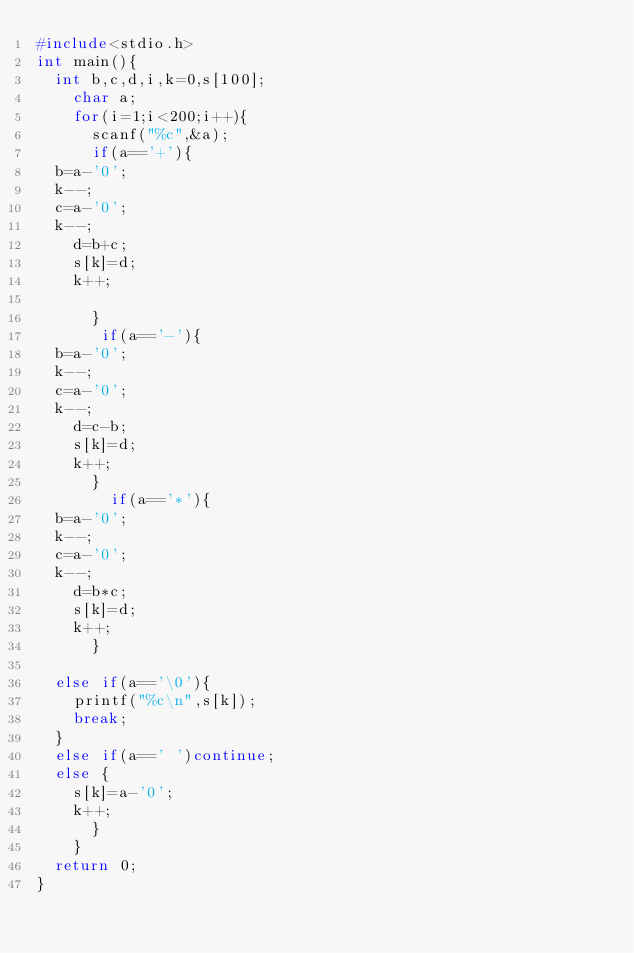Convert code to text. <code><loc_0><loc_0><loc_500><loc_500><_C_>#include<stdio.h>
int main(){
  int b,c,d,i,k=0,s[100];
    char a;
    for(i=1;i<200;i++){
      scanf("%c",&a);
      if(a=='+'){
	b=a-'0';
	k--;
	c=a-'0';
	k--;
    d=b+c;
    s[k]=d;
    k++;
   
      }
       if(a=='-'){
	b=a-'0';
	k--;
	c=a-'0';
	k--;
    d=c-b;
    s[k]=d;
    k++;
      }
        if(a=='*'){
	b=a-'0';
	k--;
	c=a-'0';
	k--;
    d=b*c;
    s[k]=d;
    k++;
      }
 
  else if(a=='\0'){
    printf("%c\n",s[k]);
    break;
  }
  else if(a==' ')continue;
  else {
    s[k]=a-'0';
    k++;
      }
    }
  return 0;
}</code> 